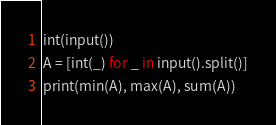<code> <loc_0><loc_0><loc_500><loc_500><_Python_>int(input())
A = [int(_) for _ in input().split()]
print(min(A), max(A), sum(A))

</code> 